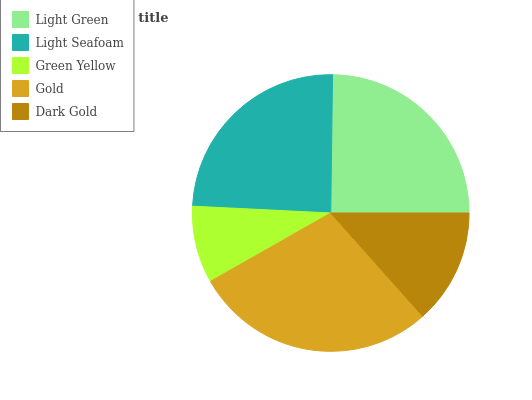Is Green Yellow the minimum?
Answer yes or no. Yes. Is Gold the maximum?
Answer yes or no. Yes. Is Light Seafoam the minimum?
Answer yes or no. No. Is Light Seafoam the maximum?
Answer yes or no. No. Is Light Green greater than Light Seafoam?
Answer yes or no. Yes. Is Light Seafoam less than Light Green?
Answer yes or no. Yes. Is Light Seafoam greater than Light Green?
Answer yes or no. No. Is Light Green less than Light Seafoam?
Answer yes or no. No. Is Light Seafoam the high median?
Answer yes or no. Yes. Is Light Seafoam the low median?
Answer yes or no. Yes. Is Dark Gold the high median?
Answer yes or no. No. Is Green Yellow the low median?
Answer yes or no. No. 